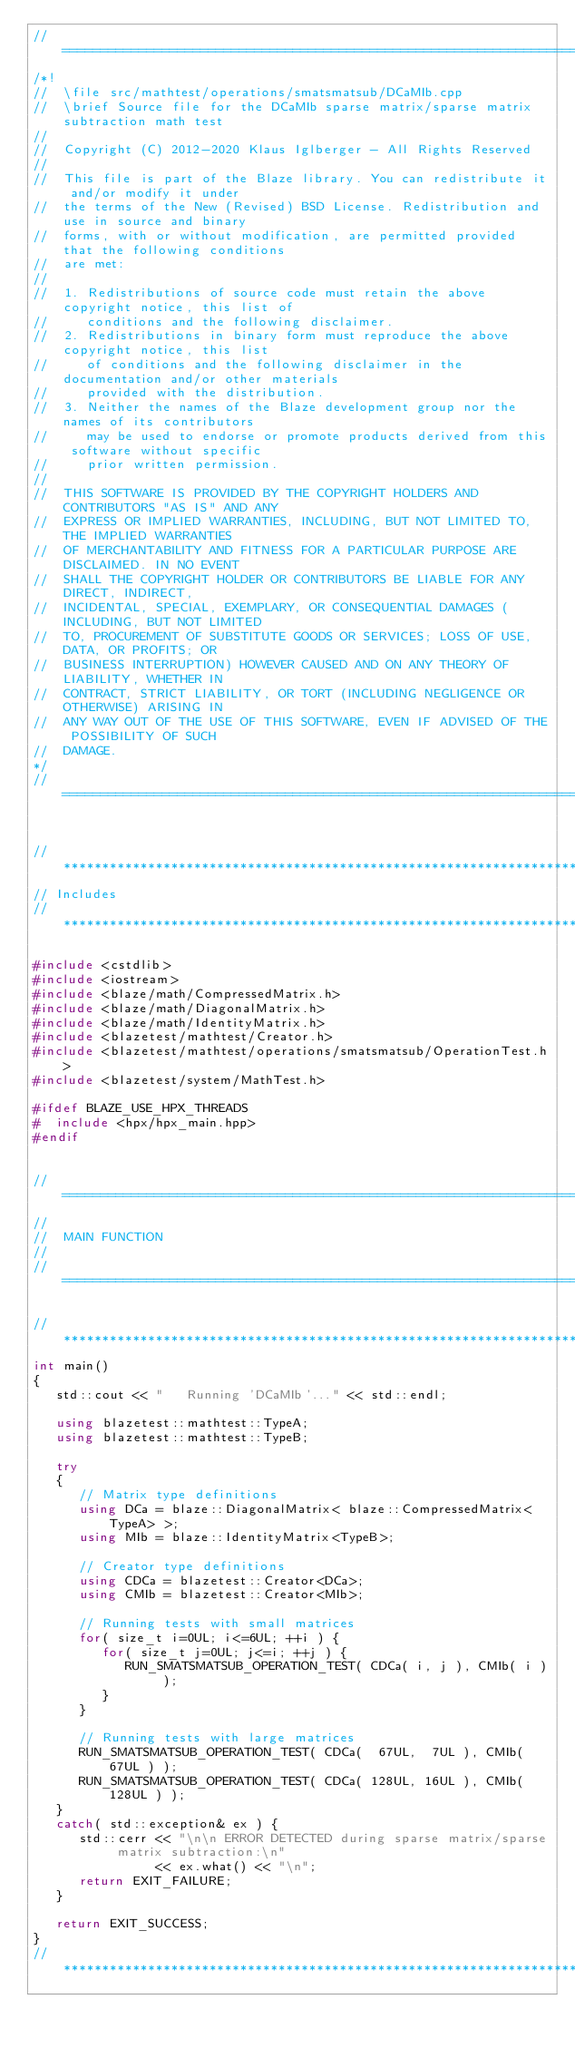<code> <loc_0><loc_0><loc_500><loc_500><_C++_>//=================================================================================================
/*!
//  \file src/mathtest/operations/smatsmatsub/DCaMIb.cpp
//  \brief Source file for the DCaMIb sparse matrix/sparse matrix subtraction math test
//
//  Copyright (C) 2012-2020 Klaus Iglberger - All Rights Reserved
//
//  This file is part of the Blaze library. You can redistribute it and/or modify it under
//  the terms of the New (Revised) BSD License. Redistribution and use in source and binary
//  forms, with or without modification, are permitted provided that the following conditions
//  are met:
//
//  1. Redistributions of source code must retain the above copyright notice, this list of
//     conditions and the following disclaimer.
//  2. Redistributions in binary form must reproduce the above copyright notice, this list
//     of conditions and the following disclaimer in the documentation and/or other materials
//     provided with the distribution.
//  3. Neither the names of the Blaze development group nor the names of its contributors
//     may be used to endorse or promote products derived from this software without specific
//     prior written permission.
//
//  THIS SOFTWARE IS PROVIDED BY THE COPYRIGHT HOLDERS AND CONTRIBUTORS "AS IS" AND ANY
//  EXPRESS OR IMPLIED WARRANTIES, INCLUDING, BUT NOT LIMITED TO, THE IMPLIED WARRANTIES
//  OF MERCHANTABILITY AND FITNESS FOR A PARTICULAR PURPOSE ARE DISCLAIMED. IN NO EVENT
//  SHALL THE COPYRIGHT HOLDER OR CONTRIBUTORS BE LIABLE FOR ANY DIRECT, INDIRECT,
//  INCIDENTAL, SPECIAL, EXEMPLARY, OR CONSEQUENTIAL DAMAGES (INCLUDING, BUT NOT LIMITED
//  TO, PROCUREMENT OF SUBSTITUTE GOODS OR SERVICES; LOSS OF USE, DATA, OR PROFITS; OR
//  BUSINESS INTERRUPTION) HOWEVER CAUSED AND ON ANY THEORY OF LIABILITY, WHETHER IN
//  CONTRACT, STRICT LIABILITY, OR TORT (INCLUDING NEGLIGENCE OR OTHERWISE) ARISING IN
//  ANY WAY OUT OF THE USE OF THIS SOFTWARE, EVEN IF ADVISED OF THE POSSIBILITY OF SUCH
//  DAMAGE.
*/
//=================================================================================================


//*************************************************************************************************
// Includes
//*************************************************************************************************

#include <cstdlib>
#include <iostream>
#include <blaze/math/CompressedMatrix.h>
#include <blaze/math/DiagonalMatrix.h>
#include <blaze/math/IdentityMatrix.h>
#include <blazetest/mathtest/Creator.h>
#include <blazetest/mathtest/operations/smatsmatsub/OperationTest.h>
#include <blazetest/system/MathTest.h>

#ifdef BLAZE_USE_HPX_THREADS
#  include <hpx/hpx_main.hpp>
#endif


//=================================================================================================
//
//  MAIN FUNCTION
//
//=================================================================================================

//*************************************************************************************************
int main()
{
   std::cout << "   Running 'DCaMIb'..." << std::endl;

   using blazetest::mathtest::TypeA;
   using blazetest::mathtest::TypeB;

   try
   {
      // Matrix type definitions
      using DCa = blaze::DiagonalMatrix< blaze::CompressedMatrix<TypeA> >;
      using MIb = blaze::IdentityMatrix<TypeB>;

      // Creator type definitions
      using CDCa = blazetest::Creator<DCa>;
      using CMIb = blazetest::Creator<MIb>;

      // Running tests with small matrices
      for( size_t i=0UL; i<=6UL; ++i ) {
         for( size_t j=0UL; j<=i; ++j ) {
            RUN_SMATSMATSUB_OPERATION_TEST( CDCa( i, j ), CMIb( i ) );
         }
      }

      // Running tests with large matrices
      RUN_SMATSMATSUB_OPERATION_TEST( CDCa(  67UL,  7UL ), CMIb(  67UL ) );
      RUN_SMATSMATSUB_OPERATION_TEST( CDCa( 128UL, 16UL ), CMIb( 128UL ) );
   }
   catch( std::exception& ex ) {
      std::cerr << "\n\n ERROR DETECTED during sparse matrix/sparse matrix subtraction:\n"
                << ex.what() << "\n";
      return EXIT_FAILURE;
   }

   return EXIT_SUCCESS;
}
//*************************************************************************************************
</code> 